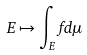<formula> <loc_0><loc_0><loc_500><loc_500>E \mapsto \int _ { E } f d \mu</formula> 